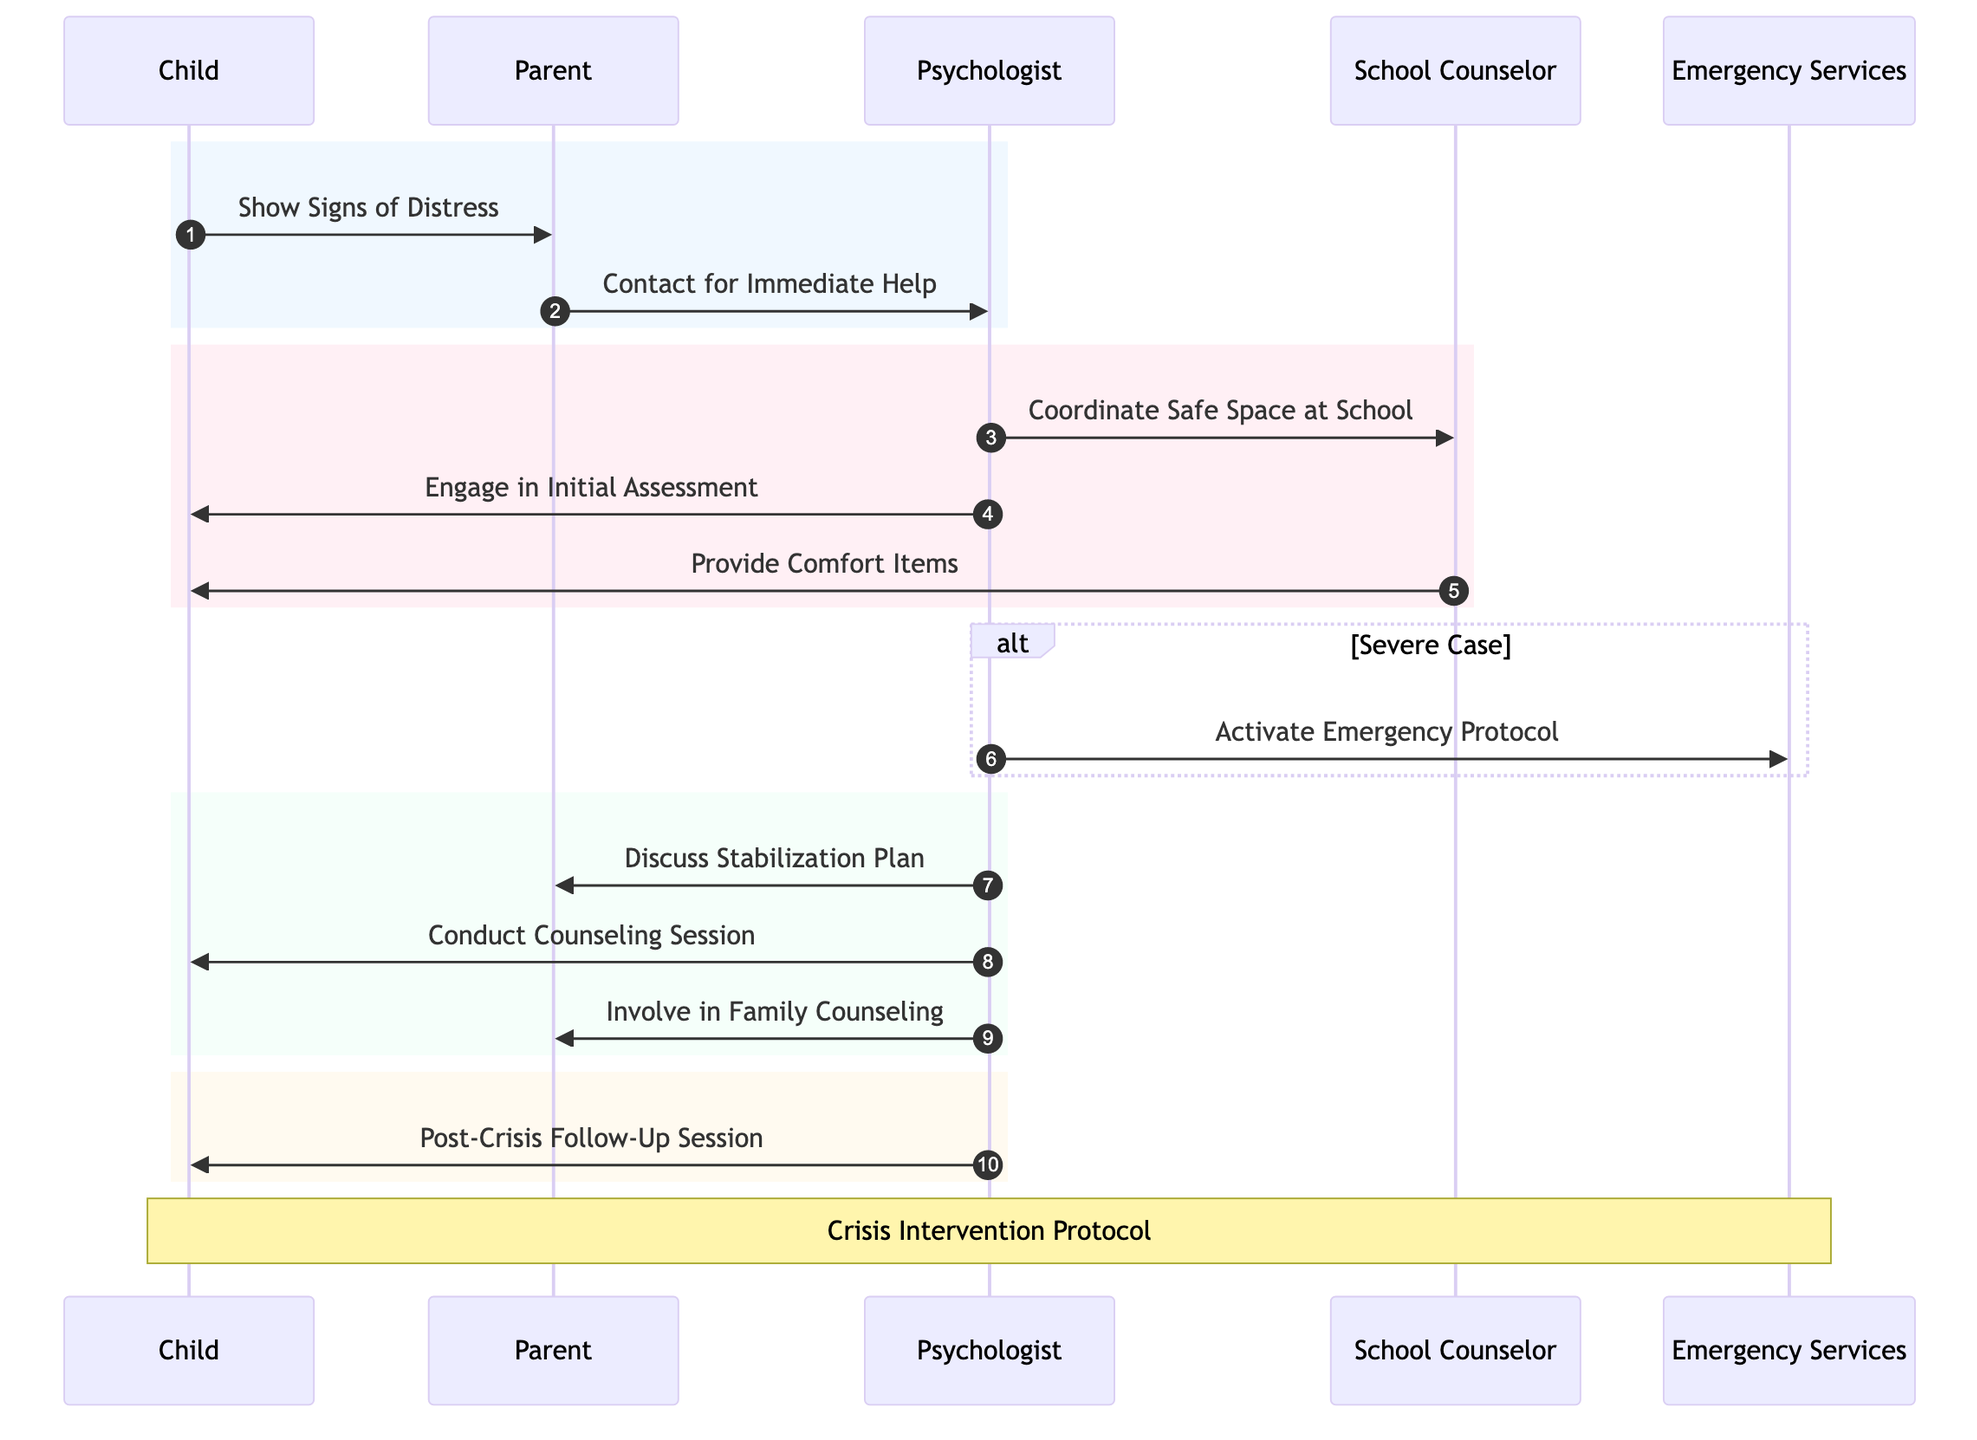What is the role of the Child in the diagram? The Child is represented as the patient in the intervention process. Their actions initiate the protocol by showing signs of distress that trigger the subsequent responses from the Parent and Psychologist.
Answer: Patient How many actors are involved in the Crisis Intervention Protocol? The diagram shows five actors: Child, Parent, Psychologist, School Counselor, and Emergency Services. Counting these provides the total number of actors involved in the process.
Answer: Five What is the first message sent in the sequence? The first message is from the Child, where they show signs of distress to the Parent. This action triggers the immediate step of contacting the Psychologist for help.
Answer: Show Signs of Distress Who coordinates the Safe Space at school? The Psychologist is the one who coordinates the Safe Space at school, as indicated by the message sent to the School Counselor.
Answer: Psychologist What happens if the case is severe? If the case is severe, the Psychologist activates the Emergency Protocol, which indicates an escalation in the crisis intervention process. This message is conditionally triggered based on the severity of the child’s distress.
Answer: Activate Emergency Protocol What is involved in the "Family Involvement" process? The involvement of family occurs through the Psychologist's message to the Parent, discussing the stabilization plan and engaging them in family counseling as part of the intervention. This shows that family support is a key part of the protocol.
Answer: Family Counseling What is the diagram type used here? The diagram is a sequence diagram, which illustrates the interactions between various actors in a specific order to show the flow of the crisis intervention protocol. It emphasizes both the timing of messages and the roles of participants.
Answer: Sequence Diagram How many distinct processes are identified in the lifelines? There are five distinct processes identified in the lifelines, which include Initial Assessment, Stabilization, Counseling Session, Family Involvement, and Post-Crisis Follow-Up. Each process outlines a critical phase in the intervention.
Answer: Five 